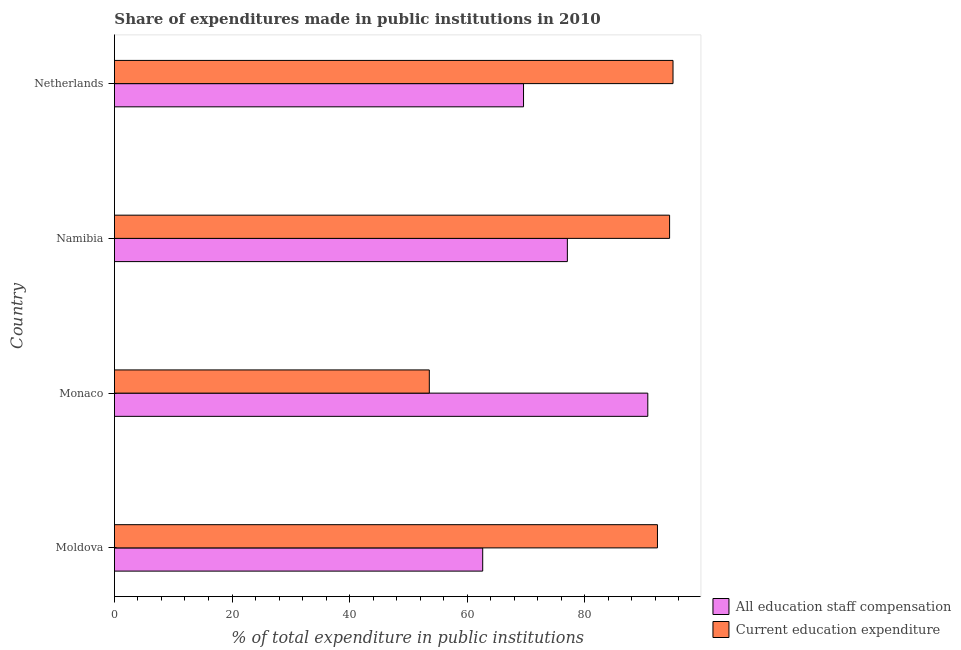How many different coloured bars are there?
Your response must be concise. 2. Are the number of bars on each tick of the Y-axis equal?
Your answer should be compact. Yes. How many bars are there on the 1st tick from the top?
Give a very brief answer. 2. How many bars are there on the 3rd tick from the bottom?
Keep it short and to the point. 2. What is the label of the 3rd group of bars from the top?
Your answer should be compact. Monaco. In how many cases, is the number of bars for a given country not equal to the number of legend labels?
Give a very brief answer. 0. What is the expenditure in staff compensation in Moldova?
Provide a short and direct response. 62.65. Across all countries, what is the maximum expenditure in education?
Your answer should be very brief. 95.02. Across all countries, what is the minimum expenditure in education?
Your response must be concise. 53.56. In which country was the expenditure in staff compensation maximum?
Your response must be concise. Monaco. In which country was the expenditure in education minimum?
Make the answer very short. Monaco. What is the total expenditure in staff compensation in the graph?
Make the answer very short. 300.01. What is the difference between the expenditure in staff compensation in Monaco and that in Namibia?
Keep it short and to the point. 13.68. What is the difference between the expenditure in education in Moldova and the expenditure in staff compensation in Namibia?
Provide a short and direct response. 15.33. What is the average expenditure in staff compensation per country?
Offer a terse response. 75. What is the difference between the expenditure in staff compensation and expenditure in education in Namibia?
Keep it short and to the point. -17.39. In how many countries, is the expenditure in staff compensation greater than 92 %?
Provide a short and direct response. 0. What is the ratio of the expenditure in staff compensation in Monaco to that in Netherlands?
Offer a very short reply. 1.3. What is the difference between the highest and the second highest expenditure in education?
Give a very brief answer. 0.58. What is the difference between the highest and the lowest expenditure in staff compensation?
Give a very brief answer. 28.08. In how many countries, is the expenditure in education greater than the average expenditure in education taken over all countries?
Keep it short and to the point. 3. Is the sum of the expenditure in education in Moldova and Namibia greater than the maximum expenditure in staff compensation across all countries?
Your response must be concise. Yes. What does the 2nd bar from the top in Namibia represents?
Your answer should be compact. All education staff compensation. What does the 2nd bar from the bottom in Moldova represents?
Your answer should be very brief. Current education expenditure. How many countries are there in the graph?
Your response must be concise. 4. What is the difference between two consecutive major ticks on the X-axis?
Give a very brief answer. 20. Are the values on the major ticks of X-axis written in scientific E-notation?
Make the answer very short. No. Does the graph contain any zero values?
Your answer should be very brief. No. Does the graph contain grids?
Ensure brevity in your answer.  No. How are the legend labels stacked?
Provide a succinct answer. Vertical. What is the title of the graph?
Your answer should be very brief. Share of expenditures made in public institutions in 2010. Does "Taxes" appear as one of the legend labels in the graph?
Provide a succinct answer. No. What is the label or title of the X-axis?
Offer a terse response. % of total expenditure in public institutions. What is the % of total expenditure in public institutions in All education staff compensation in Moldova?
Your answer should be compact. 62.65. What is the % of total expenditure in public institutions of Current education expenditure in Moldova?
Keep it short and to the point. 92.37. What is the % of total expenditure in public institutions in All education staff compensation in Monaco?
Your response must be concise. 90.73. What is the % of total expenditure in public institutions in Current education expenditure in Monaco?
Provide a succinct answer. 53.56. What is the % of total expenditure in public institutions of All education staff compensation in Namibia?
Ensure brevity in your answer.  77.05. What is the % of total expenditure in public institutions of Current education expenditure in Namibia?
Provide a succinct answer. 94.44. What is the % of total expenditure in public institutions in All education staff compensation in Netherlands?
Your answer should be very brief. 69.59. What is the % of total expenditure in public institutions of Current education expenditure in Netherlands?
Your answer should be very brief. 95.02. Across all countries, what is the maximum % of total expenditure in public institutions of All education staff compensation?
Provide a succinct answer. 90.73. Across all countries, what is the maximum % of total expenditure in public institutions in Current education expenditure?
Your answer should be very brief. 95.02. Across all countries, what is the minimum % of total expenditure in public institutions in All education staff compensation?
Your answer should be very brief. 62.65. Across all countries, what is the minimum % of total expenditure in public institutions of Current education expenditure?
Your answer should be very brief. 53.56. What is the total % of total expenditure in public institutions in All education staff compensation in the graph?
Give a very brief answer. 300.01. What is the total % of total expenditure in public institutions of Current education expenditure in the graph?
Offer a terse response. 335.39. What is the difference between the % of total expenditure in public institutions of All education staff compensation in Moldova and that in Monaco?
Give a very brief answer. -28.08. What is the difference between the % of total expenditure in public institutions in Current education expenditure in Moldova and that in Monaco?
Your answer should be compact. 38.81. What is the difference between the % of total expenditure in public institutions in All education staff compensation in Moldova and that in Namibia?
Your answer should be very brief. -14.4. What is the difference between the % of total expenditure in public institutions in Current education expenditure in Moldova and that in Namibia?
Your answer should be very brief. -2.07. What is the difference between the % of total expenditure in public institutions of All education staff compensation in Moldova and that in Netherlands?
Offer a terse response. -6.94. What is the difference between the % of total expenditure in public institutions in Current education expenditure in Moldova and that in Netherlands?
Provide a succinct answer. -2.65. What is the difference between the % of total expenditure in public institutions of All education staff compensation in Monaco and that in Namibia?
Provide a succinct answer. 13.68. What is the difference between the % of total expenditure in public institutions of Current education expenditure in Monaco and that in Namibia?
Offer a very short reply. -40.87. What is the difference between the % of total expenditure in public institutions in All education staff compensation in Monaco and that in Netherlands?
Give a very brief answer. 21.14. What is the difference between the % of total expenditure in public institutions of Current education expenditure in Monaco and that in Netherlands?
Your answer should be very brief. -41.46. What is the difference between the % of total expenditure in public institutions in All education staff compensation in Namibia and that in Netherlands?
Your answer should be very brief. 7.45. What is the difference between the % of total expenditure in public institutions of Current education expenditure in Namibia and that in Netherlands?
Provide a short and direct response. -0.58. What is the difference between the % of total expenditure in public institutions in All education staff compensation in Moldova and the % of total expenditure in public institutions in Current education expenditure in Monaco?
Offer a very short reply. 9.08. What is the difference between the % of total expenditure in public institutions in All education staff compensation in Moldova and the % of total expenditure in public institutions in Current education expenditure in Namibia?
Keep it short and to the point. -31.79. What is the difference between the % of total expenditure in public institutions in All education staff compensation in Moldova and the % of total expenditure in public institutions in Current education expenditure in Netherlands?
Provide a short and direct response. -32.37. What is the difference between the % of total expenditure in public institutions of All education staff compensation in Monaco and the % of total expenditure in public institutions of Current education expenditure in Namibia?
Ensure brevity in your answer.  -3.71. What is the difference between the % of total expenditure in public institutions of All education staff compensation in Monaco and the % of total expenditure in public institutions of Current education expenditure in Netherlands?
Provide a succinct answer. -4.29. What is the difference between the % of total expenditure in public institutions in All education staff compensation in Namibia and the % of total expenditure in public institutions in Current education expenditure in Netherlands?
Give a very brief answer. -17.97. What is the average % of total expenditure in public institutions of All education staff compensation per country?
Keep it short and to the point. 75. What is the average % of total expenditure in public institutions in Current education expenditure per country?
Offer a terse response. 83.85. What is the difference between the % of total expenditure in public institutions in All education staff compensation and % of total expenditure in public institutions in Current education expenditure in Moldova?
Offer a very short reply. -29.72. What is the difference between the % of total expenditure in public institutions of All education staff compensation and % of total expenditure in public institutions of Current education expenditure in Monaco?
Give a very brief answer. 37.17. What is the difference between the % of total expenditure in public institutions in All education staff compensation and % of total expenditure in public institutions in Current education expenditure in Namibia?
Make the answer very short. -17.39. What is the difference between the % of total expenditure in public institutions of All education staff compensation and % of total expenditure in public institutions of Current education expenditure in Netherlands?
Your response must be concise. -25.43. What is the ratio of the % of total expenditure in public institutions in All education staff compensation in Moldova to that in Monaco?
Your response must be concise. 0.69. What is the ratio of the % of total expenditure in public institutions in Current education expenditure in Moldova to that in Monaco?
Keep it short and to the point. 1.72. What is the ratio of the % of total expenditure in public institutions of All education staff compensation in Moldova to that in Namibia?
Offer a terse response. 0.81. What is the ratio of the % of total expenditure in public institutions in Current education expenditure in Moldova to that in Namibia?
Provide a short and direct response. 0.98. What is the ratio of the % of total expenditure in public institutions in All education staff compensation in Moldova to that in Netherlands?
Your response must be concise. 0.9. What is the ratio of the % of total expenditure in public institutions in Current education expenditure in Moldova to that in Netherlands?
Provide a succinct answer. 0.97. What is the ratio of the % of total expenditure in public institutions in All education staff compensation in Monaco to that in Namibia?
Provide a short and direct response. 1.18. What is the ratio of the % of total expenditure in public institutions in Current education expenditure in Monaco to that in Namibia?
Give a very brief answer. 0.57. What is the ratio of the % of total expenditure in public institutions in All education staff compensation in Monaco to that in Netherlands?
Your response must be concise. 1.3. What is the ratio of the % of total expenditure in public institutions of Current education expenditure in Monaco to that in Netherlands?
Provide a short and direct response. 0.56. What is the ratio of the % of total expenditure in public institutions of All education staff compensation in Namibia to that in Netherlands?
Ensure brevity in your answer.  1.11. What is the ratio of the % of total expenditure in public institutions of Current education expenditure in Namibia to that in Netherlands?
Keep it short and to the point. 0.99. What is the difference between the highest and the second highest % of total expenditure in public institutions of All education staff compensation?
Keep it short and to the point. 13.68. What is the difference between the highest and the second highest % of total expenditure in public institutions in Current education expenditure?
Your answer should be very brief. 0.58. What is the difference between the highest and the lowest % of total expenditure in public institutions of All education staff compensation?
Keep it short and to the point. 28.08. What is the difference between the highest and the lowest % of total expenditure in public institutions of Current education expenditure?
Your answer should be compact. 41.46. 